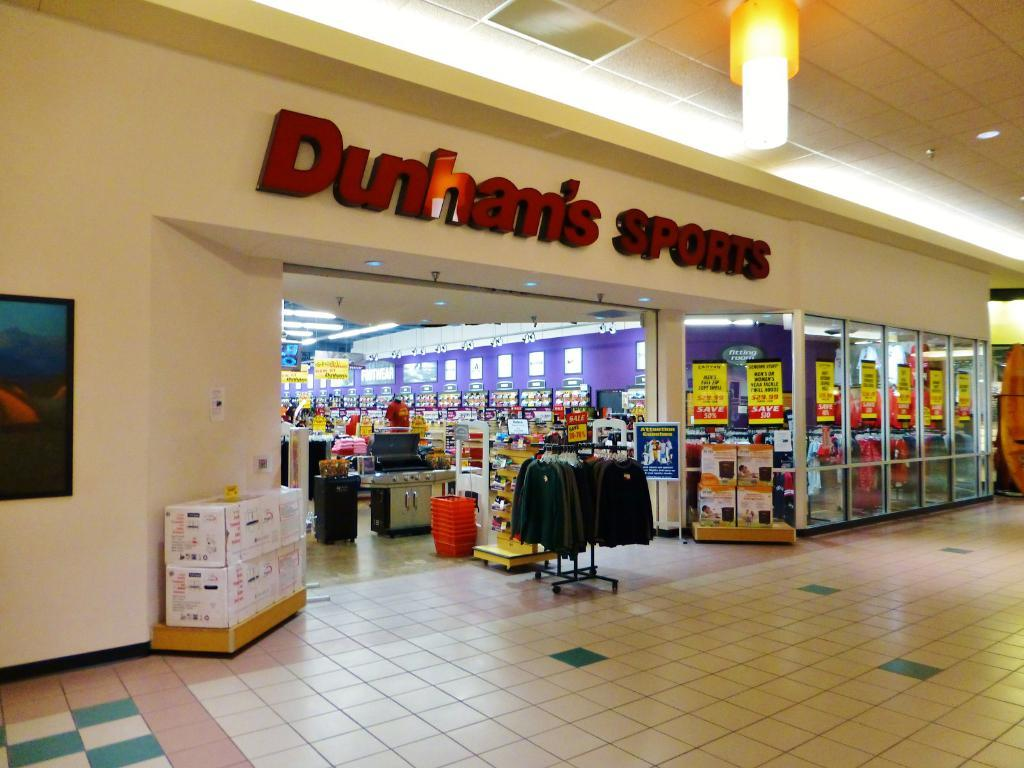What type of structure is shown in the image? There is a building in the image. What can be found inside the building? There are stores in the image. How can the stores be identified? There is a name board in the image. What type of lighting is used in the image? Electric lights are visible in the image. What type of packaging material is present in the image? Cardboard cartons are present in the image. What type of decorations are in the image? Wall hangings are in the image. What type of promotional material is present in the image? Advertisements are pasted on the doors in the image. What can be seen under the stores and decorations? The floor is visible in the image. Where is the donkey standing in the image? There is no donkey present in the image. What type of coil is wrapped around the wall hangings in the image? There is no coil present in the image; the wall hangings are not wrapped around anything. 